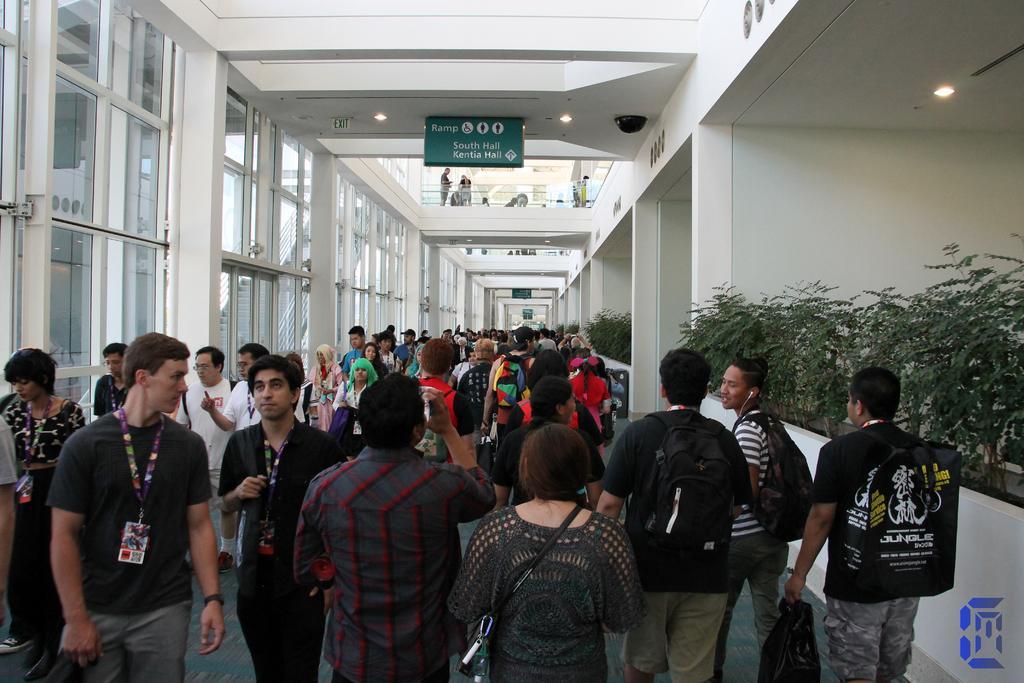Please provide a concise description of this image. In this picture we can see a group of people on the floor, plants, walls, lights, name boards, windows, some objects and in the background we can see some people. 